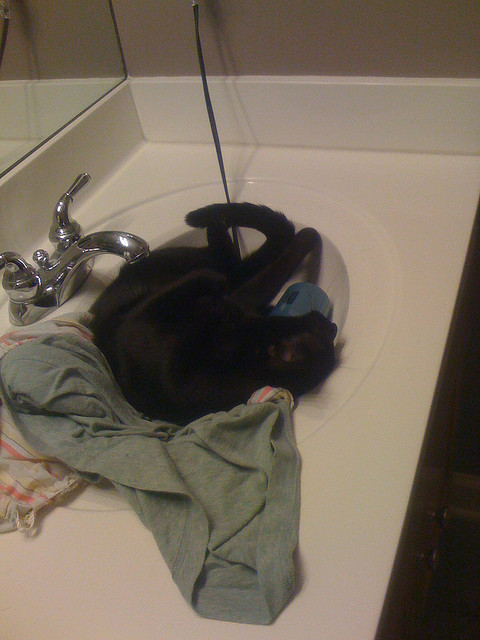Which room is the sink located in? The sink appears to be located in the bathroom. 